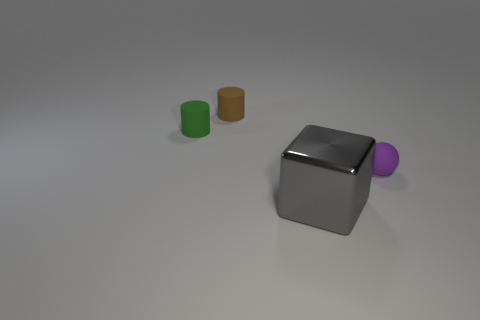Add 3 small green rubber balls. How many objects exist? 7 Subtract all green cylinders. How many cylinders are left? 1 Subtract 2 cylinders. How many cylinders are left? 0 Subtract all balls. How many objects are left? 3 Subtract all blue spheres. Subtract all red cylinders. How many spheres are left? 1 Add 3 cylinders. How many cylinders are left? 5 Add 2 tiny green cylinders. How many tiny green cylinders exist? 3 Subtract 0 red cubes. How many objects are left? 4 Subtract all blue cubes. How many brown cylinders are left? 1 Subtract all purple things. Subtract all purple things. How many objects are left? 2 